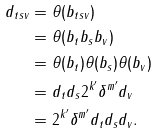<formula> <loc_0><loc_0><loc_500><loc_500>d _ { t s v } & = \theta ( b _ { t s v } ) \\ & = \theta ( b _ { t } b _ { s } b _ { v } ) \\ & = \theta ( b _ { t } ) \theta ( b _ { s } ) \theta ( b _ { v } ) \\ & = d _ { t } d _ { s } 2 ^ { k ^ { \prime } } \delta ^ { m ^ { \prime } } d _ { v } \\ & = 2 ^ { k ^ { \prime } } \delta ^ { m ^ { \prime } } d _ { t } d _ { s } d _ { v } .</formula> 